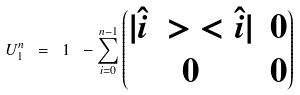Convert formula to latex. <formula><loc_0><loc_0><loc_500><loc_500>U _ { 1 } ^ { n } \ = \ 1 \ - \sum _ { i = 0 } ^ { n - 1 } \begin{pmatrix} | \hat { i } \ > \ < \hat { i } | & 0 \\ 0 & 0 \end{pmatrix}</formula> 